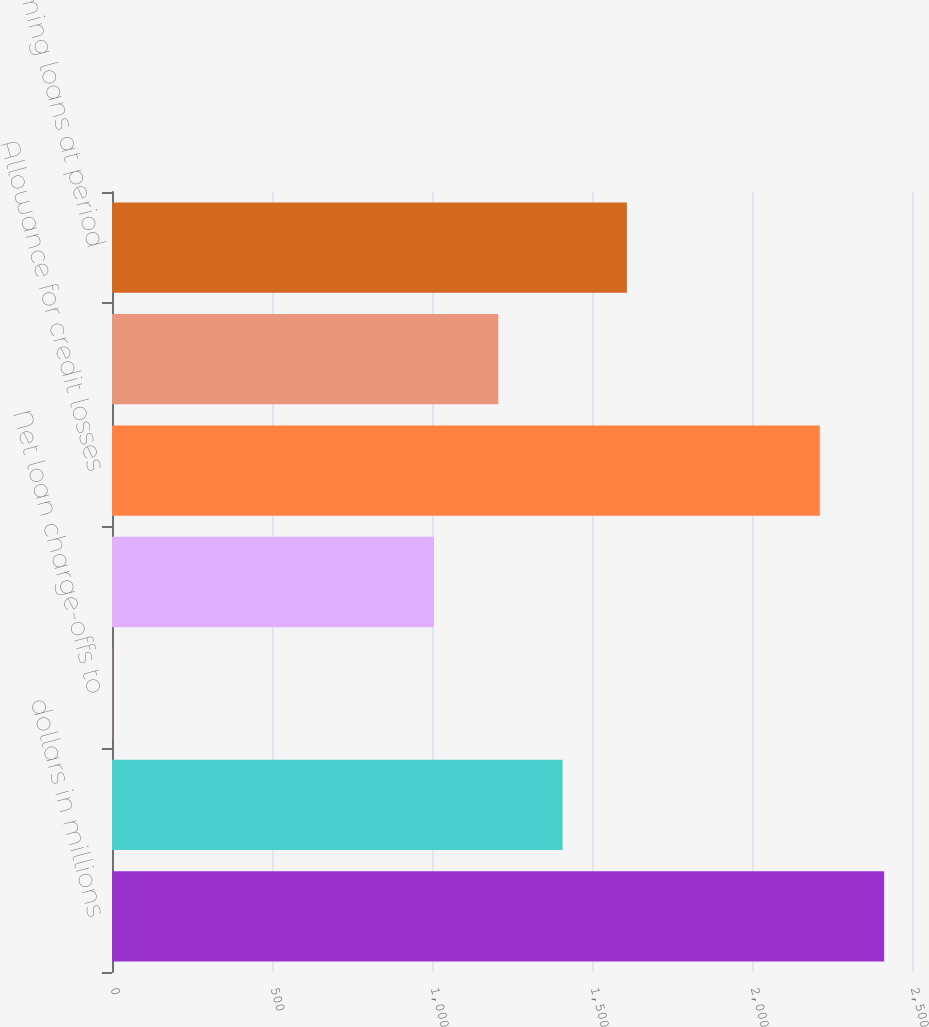Convert chart. <chart><loc_0><loc_0><loc_500><loc_500><bar_chart><fcel>dollars in millions<fcel>Net loan charge-offs<fcel>Net loan charge-offs to<fcel>Allowance for loan and lease<fcel>Allowance for credit losses<fcel>Allowance for credit losses to<fcel>Nonperforming loans at period<nl><fcel>2412.99<fcel>1408.04<fcel>1.11<fcel>1006.06<fcel>2212<fcel>1207.05<fcel>1609.03<nl></chart> 